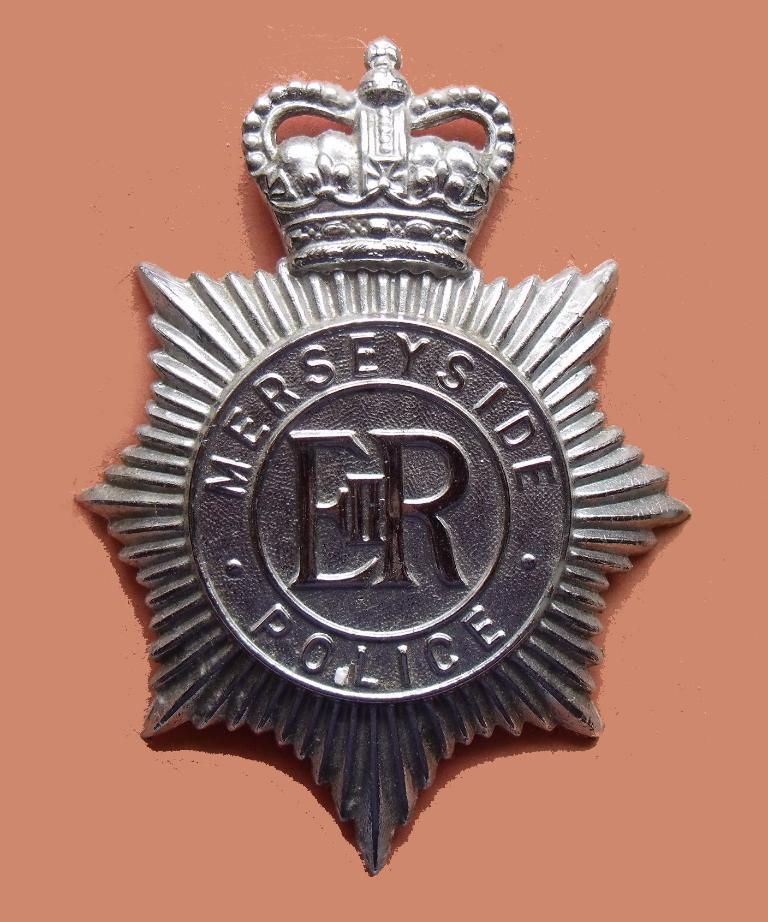What is the main subject of the image? The main subject of the image is a police badge. Is the police badge attached to anything? Yes, the police badge is on an object. What type of straw is growing near the police badge in the image? There is no straw present in the image; it only features a police badge on an object. 